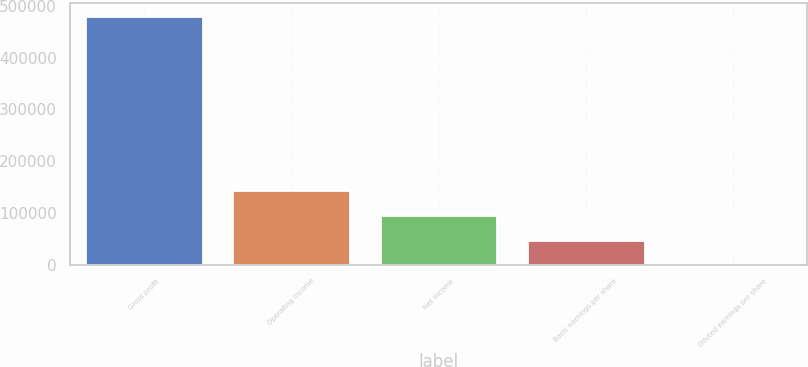Convert chart. <chart><loc_0><loc_0><loc_500><loc_500><bar_chart><fcel>Gross profit<fcel>Operating income<fcel>Net income<fcel>Basic earnings per share<fcel>Diluted earnings per share<nl><fcel>480848<fcel>144255<fcel>96169.7<fcel>48084.9<fcel>0.17<nl></chart> 